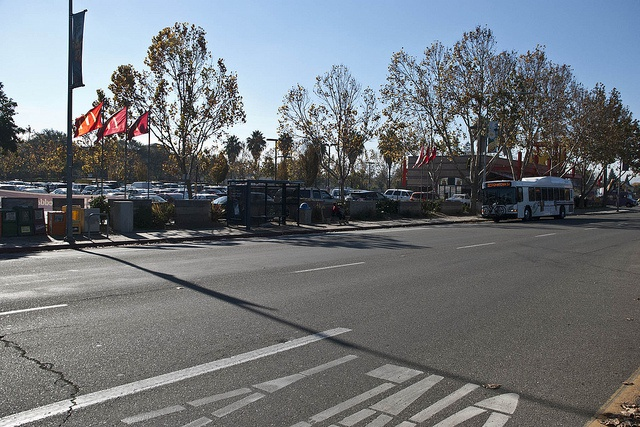Describe the objects in this image and their specific colors. I can see car in lightblue, black, gray, and darkblue tones, bus in lightblue, black, gray, and blue tones, car in lightblue, black, gray, navy, and darkblue tones, car in lightblue, gray, black, and lightgray tones, and car in lightblue, black, gray, and darkgray tones in this image. 